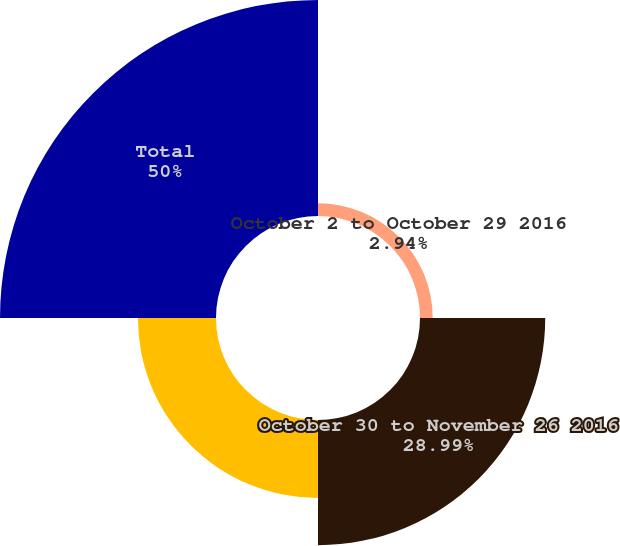Convert chart. <chart><loc_0><loc_0><loc_500><loc_500><pie_chart><fcel>October 2 to October 29 2016<fcel>October 30 to November 26 2016<fcel>November 27 to December 31<fcel>Total<nl><fcel>2.94%<fcel>28.99%<fcel>18.07%<fcel>50.0%<nl></chart> 